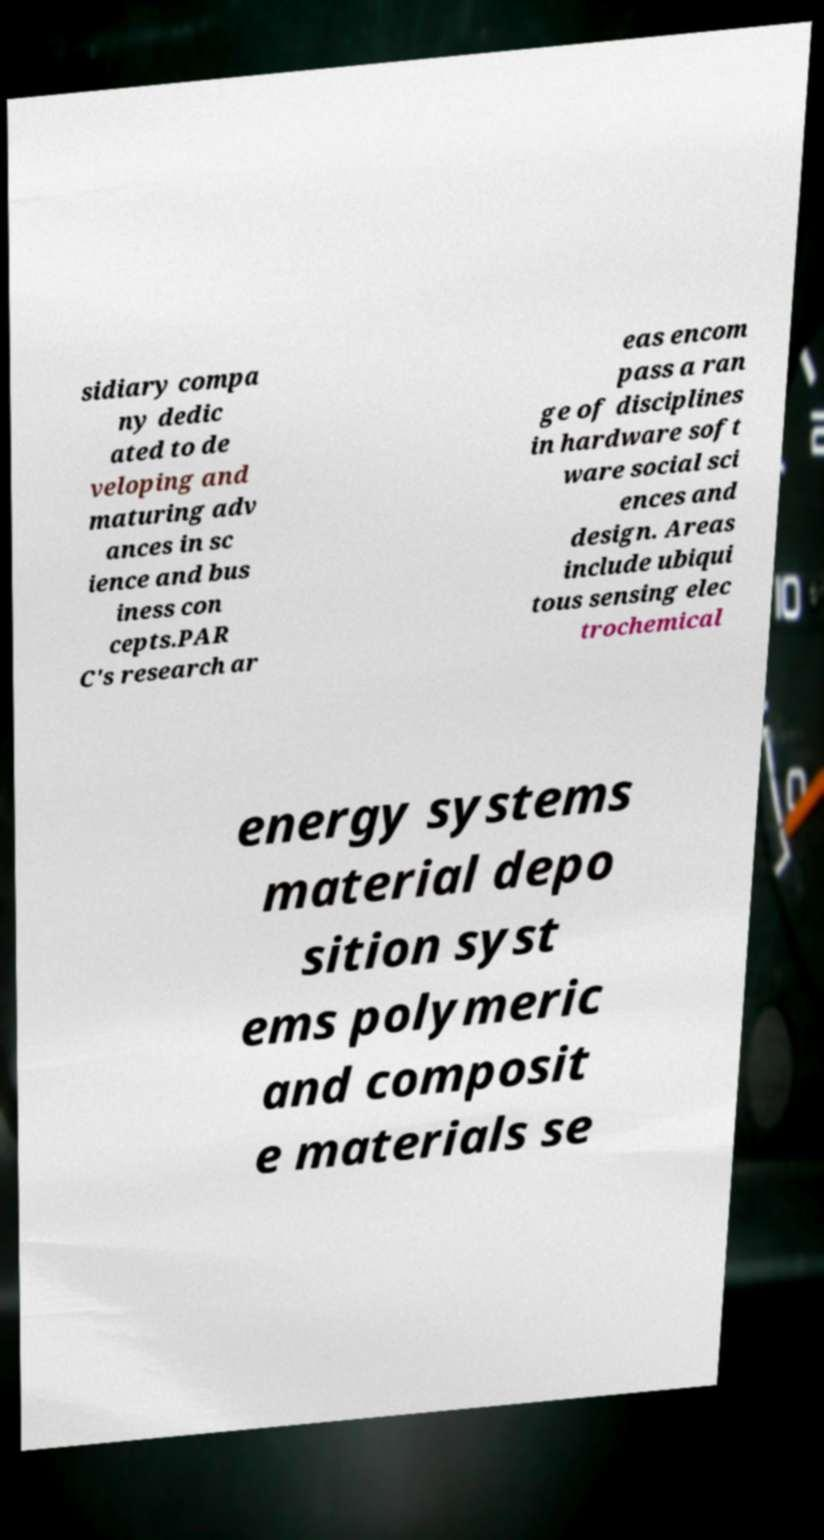What messages or text are displayed in this image? I need them in a readable, typed format. sidiary compa ny dedic ated to de veloping and maturing adv ances in sc ience and bus iness con cepts.PAR C's research ar eas encom pass a ran ge of disciplines in hardware soft ware social sci ences and design. Areas include ubiqui tous sensing elec trochemical energy systems material depo sition syst ems polymeric and composit e materials se 